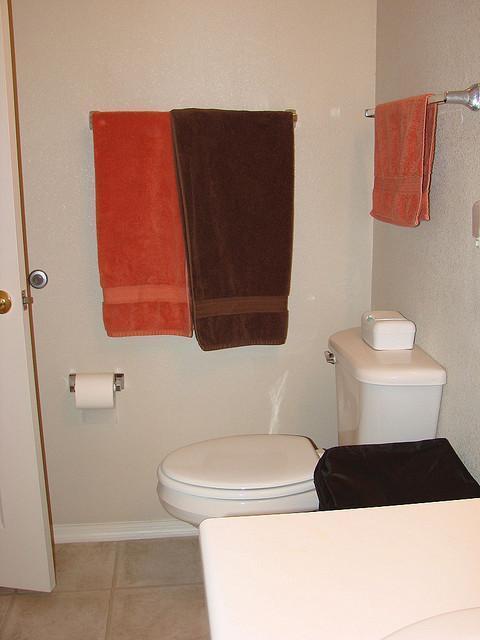How many towels are in this image?
Give a very brief answer. 3. How many frames are above the towel rack?
Give a very brief answer. 0. How many towels are on the rack?
Give a very brief answer. 3. 